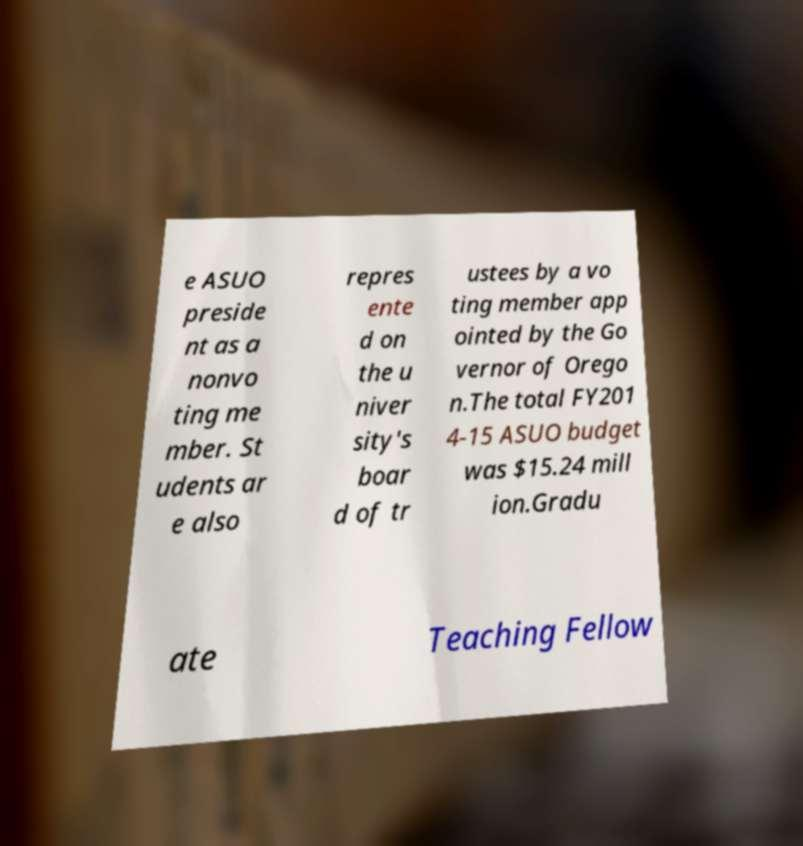Please identify and transcribe the text found in this image. e ASUO preside nt as a nonvo ting me mber. St udents ar e also repres ente d on the u niver sity's boar d of tr ustees by a vo ting member app ointed by the Go vernor of Orego n.The total FY201 4-15 ASUO budget was $15.24 mill ion.Gradu ate Teaching Fellow 